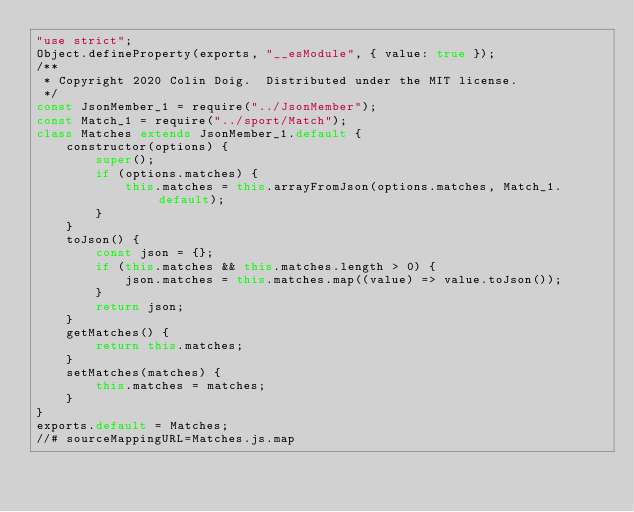<code> <loc_0><loc_0><loc_500><loc_500><_JavaScript_>"use strict";
Object.defineProperty(exports, "__esModule", { value: true });
/**
 * Copyright 2020 Colin Doig.  Distributed under the MIT license.
 */
const JsonMember_1 = require("../JsonMember");
const Match_1 = require("../sport/Match");
class Matches extends JsonMember_1.default {
    constructor(options) {
        super();
        if (options.matches) {
            this.matches = this.arrayFromJson(options.matches, Match_1.default);
        }
    }
    toJson() {
        const json = {};
        if (this.matches && this.matches.length > 0) {
            json.matches = this.matches.map((value) => value.toJson());
        }
        return json;
    }
    getMatches() {
        return this.matches;
    }
    setMatches(matches) {
        this.matches = matches;
    }
}
exports.default = Matches;
//# sourceMappingURL=Matches.js.map</code> 